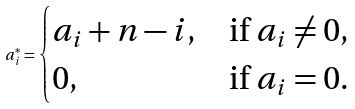Convert formula to latex. <formula><loc_0><loc_0><loc_500><loc_500>a _ { i } ^ { * } = \begin{cases} a _ { i } + n - i , & \text {if} \ a _ { i } \neq 0 , \\ 0 , & \text {if} \ a _ { i } = 0 . \end{cases}</formula> 